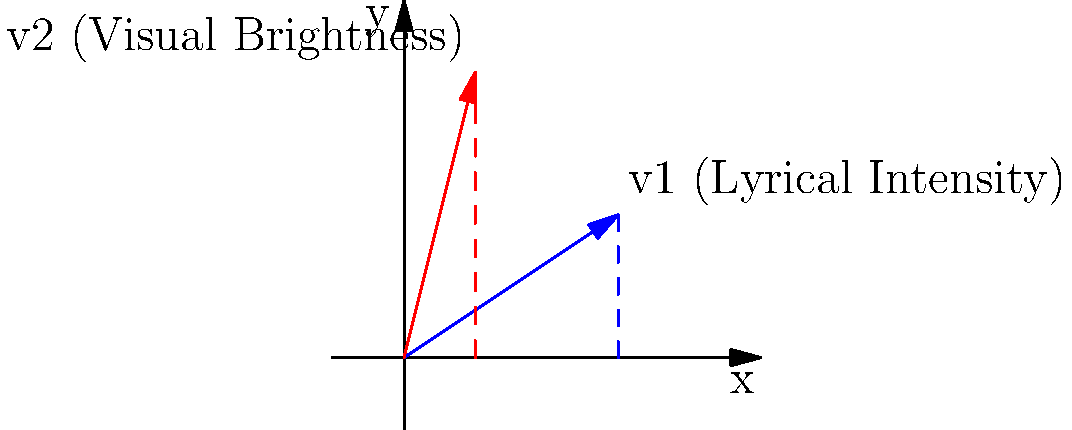As a filmmaker creating a music video, you want to synchronize the stage lighting intensity with the lyrical themes. You represent the lyrical intensity as vector $\mathbf{v_1} = (3, 2)$ and the visual brightness as vector $\mathbf{v_2} = (1, 4)$. Calculate the dot product of these vectors to determine the overall lighting effect. What is the resulting scalar value that represents the combined impact of lyrical intensity and visual brightness? To solve this problem, we need to calculate the dot product of vectors $\mathbf{v_1}$ and $\mathbf{v_2}$. The dot product is a scalar value that represents the combined effect of two vectors.

Step 1: Identify the components of each vector
$\mathbf{v_1} = (3, 2)$
$\mathbf{v_2} = (1, 4)$

Step 2: Apply the dot product formula
The dot product of two vectors $\mathbf{a} = (a_1, a_2)$ and $\mathbf{b} = (b_1, b_2)$ is given by:
$\mathbf{a} \cdot \mathbf{b} = a_1b_1 + a_2b_2$

For our vectors:
$\mathbf{v_1} \cdot \mathbf{v_2} = (3 \times 1) + (2 \times 4)$

Step 3: Perform the calculation
$\mathbf{v_1} \cdot \mathbf{v_2} = 3 + 8 = 11$

The resulting scalar value of 11 represents the combined impact of lyrical intensity and visual brightness, which can be used to determine the overall lighting effect for the music video.
Answer: 11 